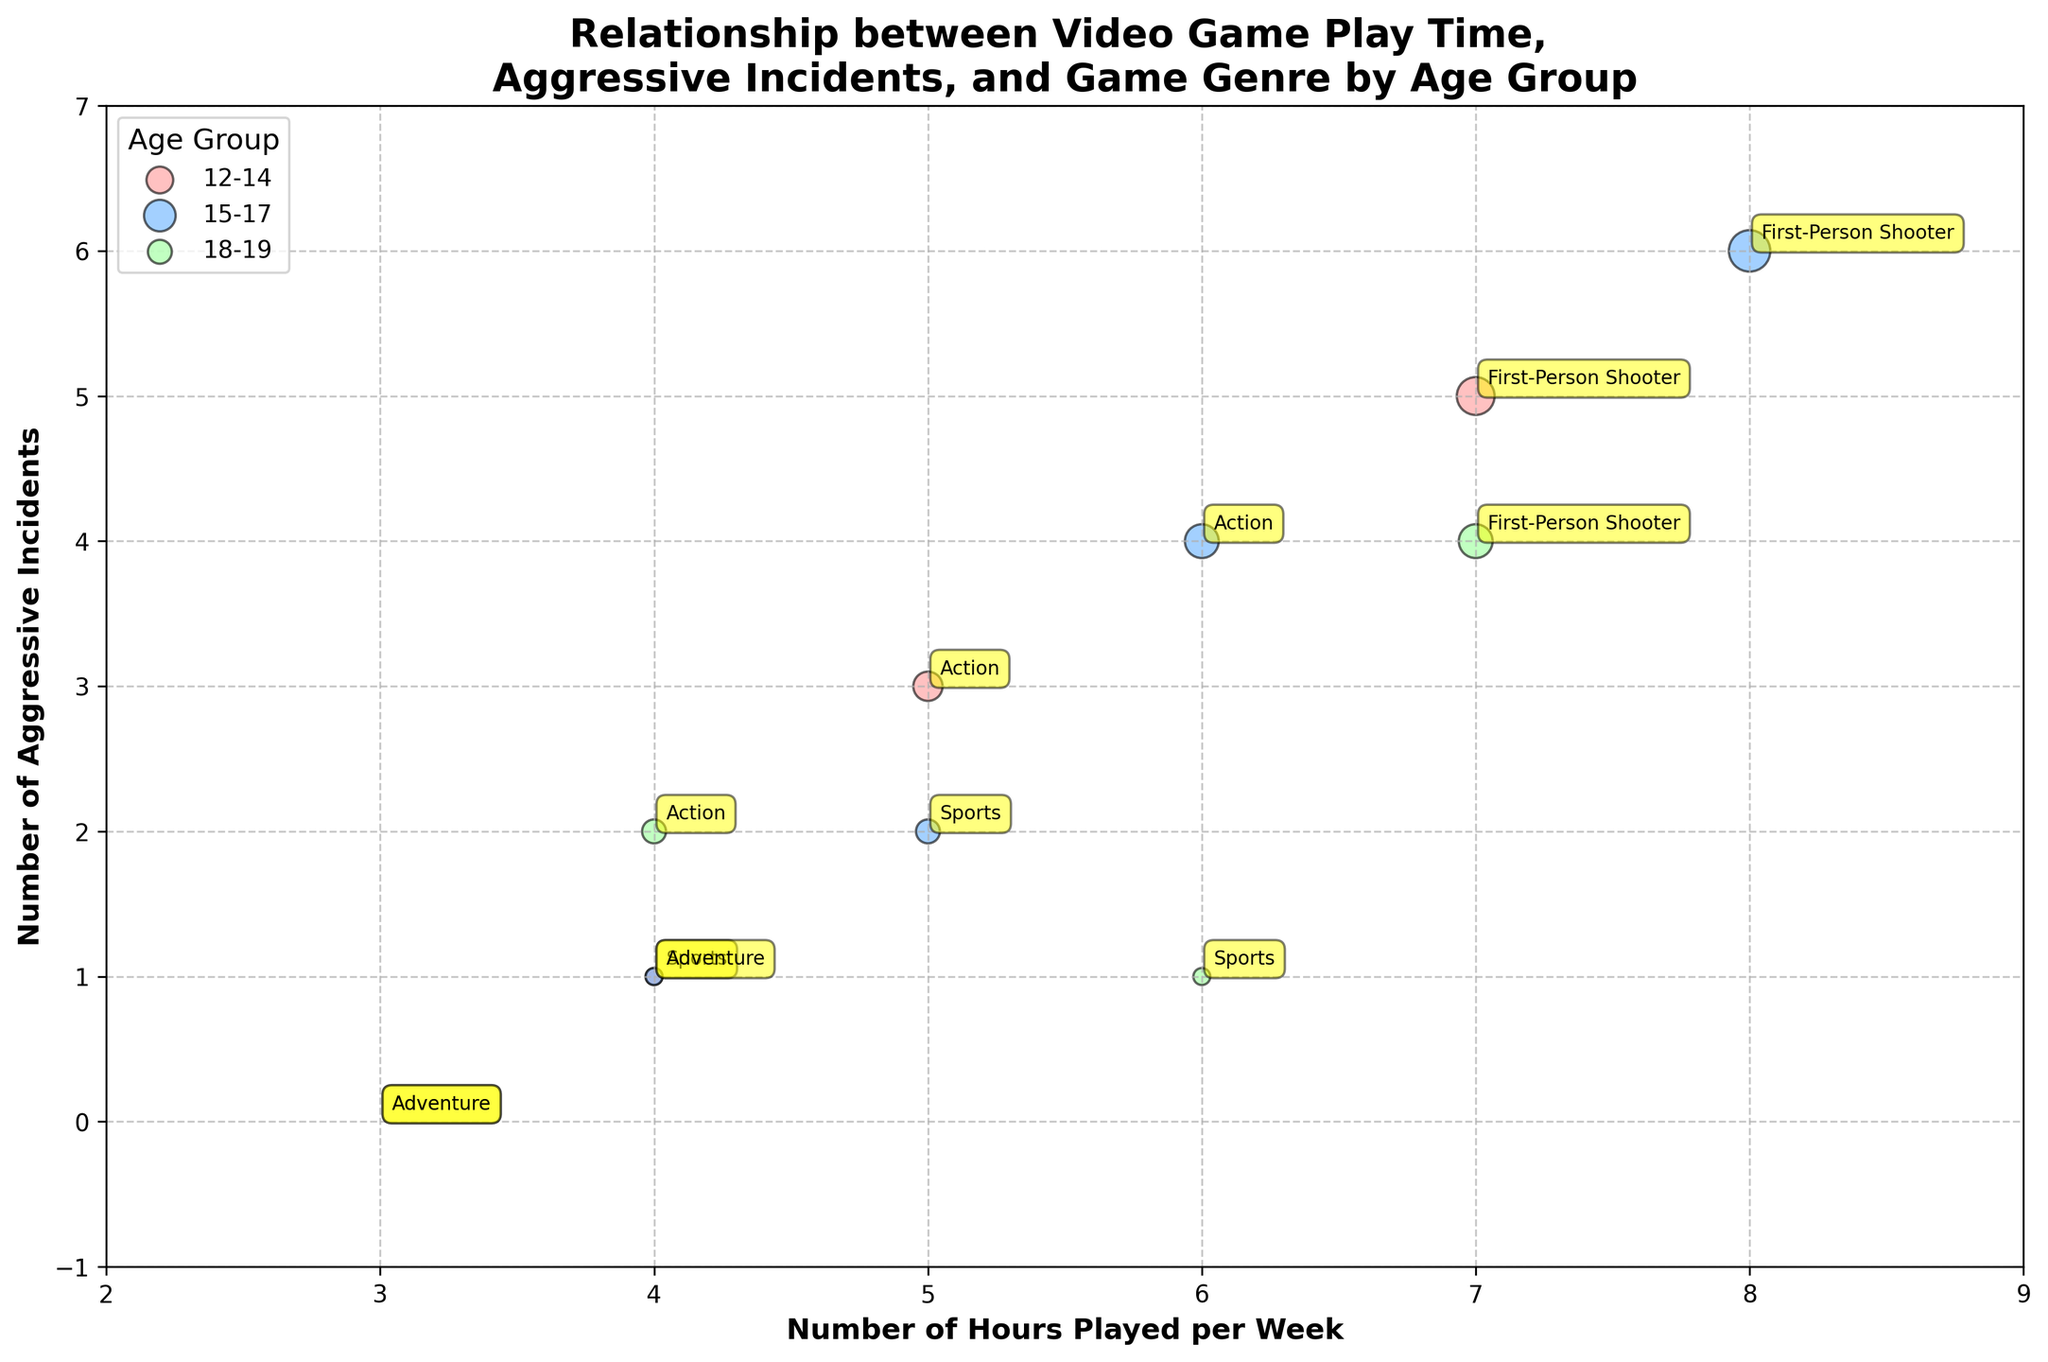Which age group has the most significant number of aggressive incidents for the First-Person Shooter genre? Look at the bubbles labeled "First-Person Shooter" and compare the number of aggressive incidents for each age group. The size of the bubble and y-axis position for the 15-17 age group is highest.
Answer: 15-17 How many aggressive incidents are there for the 12-14 age group playing Sports games? Identify the bubble labeled "Sports" within the 12-14 age group, which shows 1 aggressive incident based on its y-axis position.
Answer: 1 Which video game genre has the smallest representation in the bubble chart? Count the annotated bubbles for each genre. "Adventure" has the fewest annotations across all age groups.
Answer: Adventure What is the correlation between the Number of Hours Played per Week and the Number of Aggressive Incidents in the 15-17 age group? Observe the general trend of the bubble positions for the 15-17 age group. There seems to be a positive correlation as bubbles move upward (increasing incidents) with more hours.
Answer: Positive correlation Which age group shows the least variance in Number of Aggressive Incidents? Compare the spread of the bubbles vertically across all age groups. The 18-19 age group has bubbles grouped closer in the y-axis.
Answer: 18-19 Is there a noticeable difference in the number of aggressive incidents for Adventure games across different age groups? Look at the bubbles annotated with "Adventure" across age groups. All show zero incidents except one in the 15-17 age group.
Answer: No significant difference Compare the number of aggressive incidents for Action games between 12-14 and 18-19 age groups. Identify bubbles labeled "Action." The 12-14 age group shows 3 incidents and the 18-19 shows 2 incidents.
Answer: 12-14 has 1 more incident than 18-19 What is the most common number of aggressive incidents for the First-Person Shooter genre across all age groups? Check all bubbles labeled "First-Person Shooter" for y-axis positions. Four incidents appear most frequently.
Answer: 4 